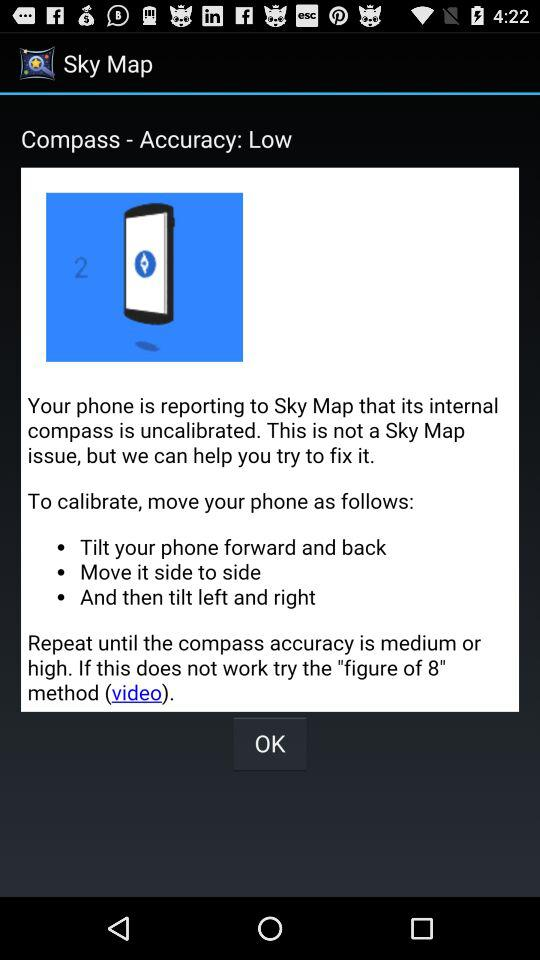What is the application name? The application name is "Sky Map". 